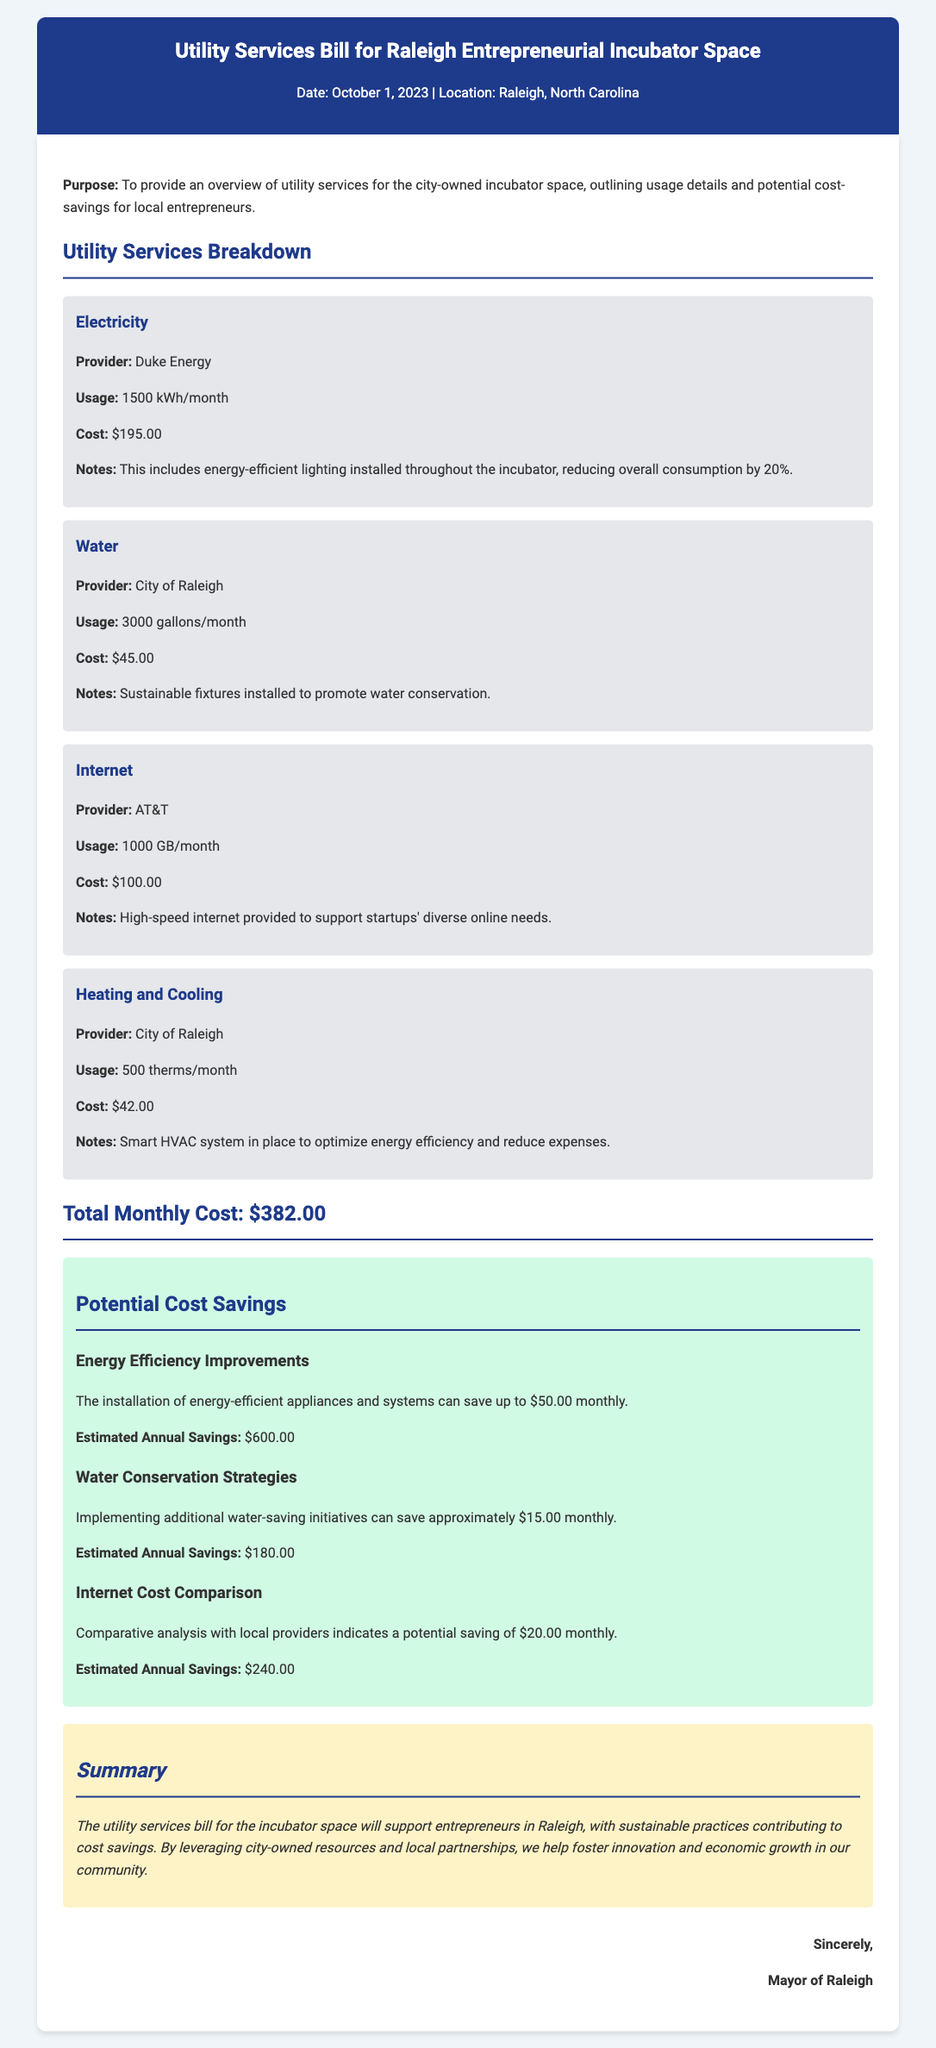what is the total monthly cost? The total monthly cost is explicitly stated in the document as the sum of all utility services costs.
Answer: $382.00 who provides the electricity? The document specifies that Duke Energy is the provider of electricity for the incubator space.
Answer: Duke Energy how much is saved through energy efficiency improvements? The potential savings from energy efficiency improvements are detailed in the document as $50.00 monthly.
Answer: $50.00 what is the water usage for the incubator space? The document provides specific details regarding water usage, which is noted in gallons per month.
Answer: 3000 gallons/month what are the sustainable fixtures installed for water? The document mentions that sustainable fixtures have been installed to promote a specific activity related to water usage.
Answer: Water conservation what is the monthly cost for heating and cooling? The document outlines the cost associated with heating and cooling services specifically in the incubator space.
Answer: $42.00 how much can be saved from water conservation strategies? The document provides an estimate of potential savings that could be achieved through specific conservation methods.
Answer: $15.00 what type of HVAC system is mentioned? The document specifies the HVAC system in place at the incubator space, characterized by an important feature related to efficiency.
Answer: Smart how much is internet usage per month? The document details the internet usage in gigabytes per month for the incubator space.
Answer: 1000 GB/month 